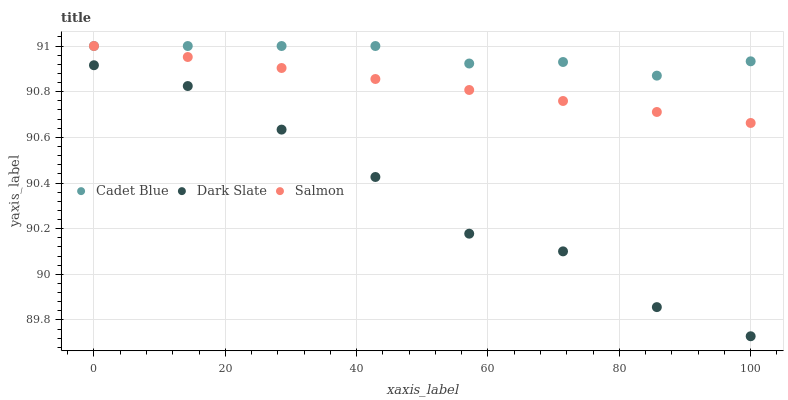Does Dark Slate have the minimum area under the curve?
Answer yes or no. Yes. Does Cadet Blue have the maximum area under the curve?
Answer yes or no. Yes. Does Salmon have the minimum area under the curve?
Answer yes or no. No. Does Salmon have the maximum area under the curve?
Answer yes or no. No. Is Salmon the smoothest?
Answer yes or no. Yes. Is Dark Slate the roughest?
Answer yes or no. Yes. Is Cadet Blue the smoothest?
Answer yes or no. No. Is Cadet Blue the roughest?
Answer yes or no. No. Does Dark Slate have the lowest value?
Answer yes or no. Yes. Does Salmon have the lowest value?
Answer yes or no. No. Does Salmon have the highest value?
Answer yes or no. Yes. Is Dark Slate less than Salmon?
Answer yes or no. Yes. Is Salmon greater than Dark Slate?
Answer yes or no. Yes. Does Salmon intersect Cadet Blue?
Answer yes or no. Yes. Is Salmon less than Cadet Blue?
Answer yes or no. No. Is Salmon greater than Cadet Blue?
Answer yes or no. No. Does Dark Slate intersect Salmon?
Answer yes or no. No. 